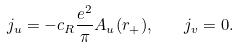Convert formula to latex. <formula><loc_0><loc_0><loc_500><loc_500>j _ { u } = - c _ { R } \frac { e ^ { 2 } } { \pi } A _ { u } ( r _ { + } ) , \quad j _ { v } = 0 .</formula> 